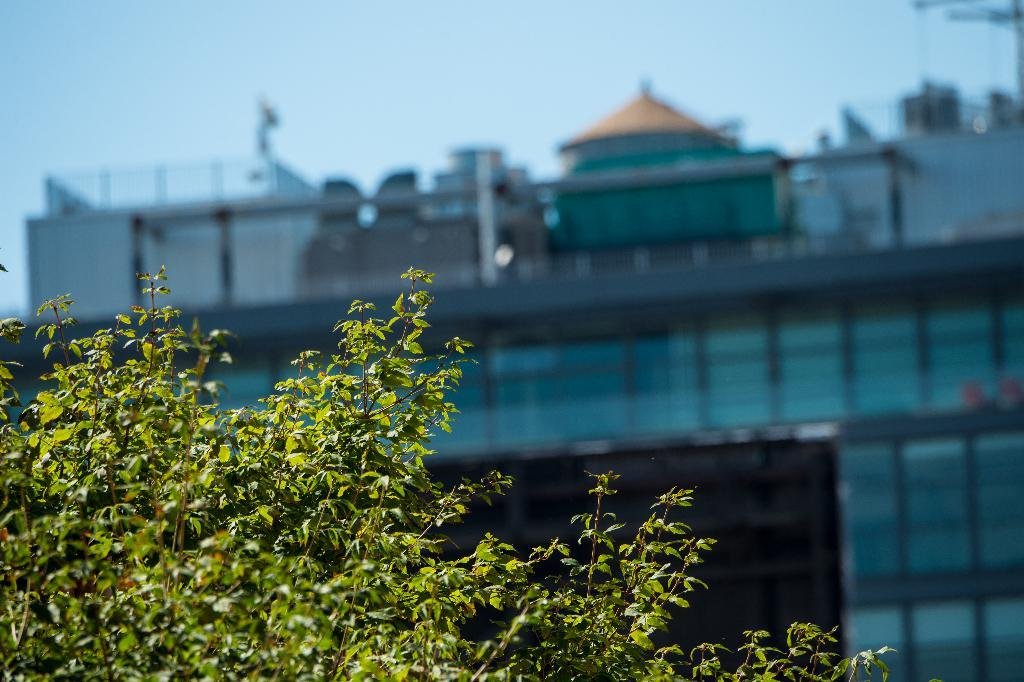What type of vegetation is visible in the front of the image? There are leaves in the front of the image. What structures can be seen in the background of the image? There is a building and a tent in the background of the image. What architectural feature is present in the background of the image? There is a railing in the background of the image. What type of canvas is being pulled by the leaves in the image? There is no canvas or pulling action involving the leaves in the image. What is the mouth of the building in the image? There is no mouth present in the image, as buildings do not have mouths. 